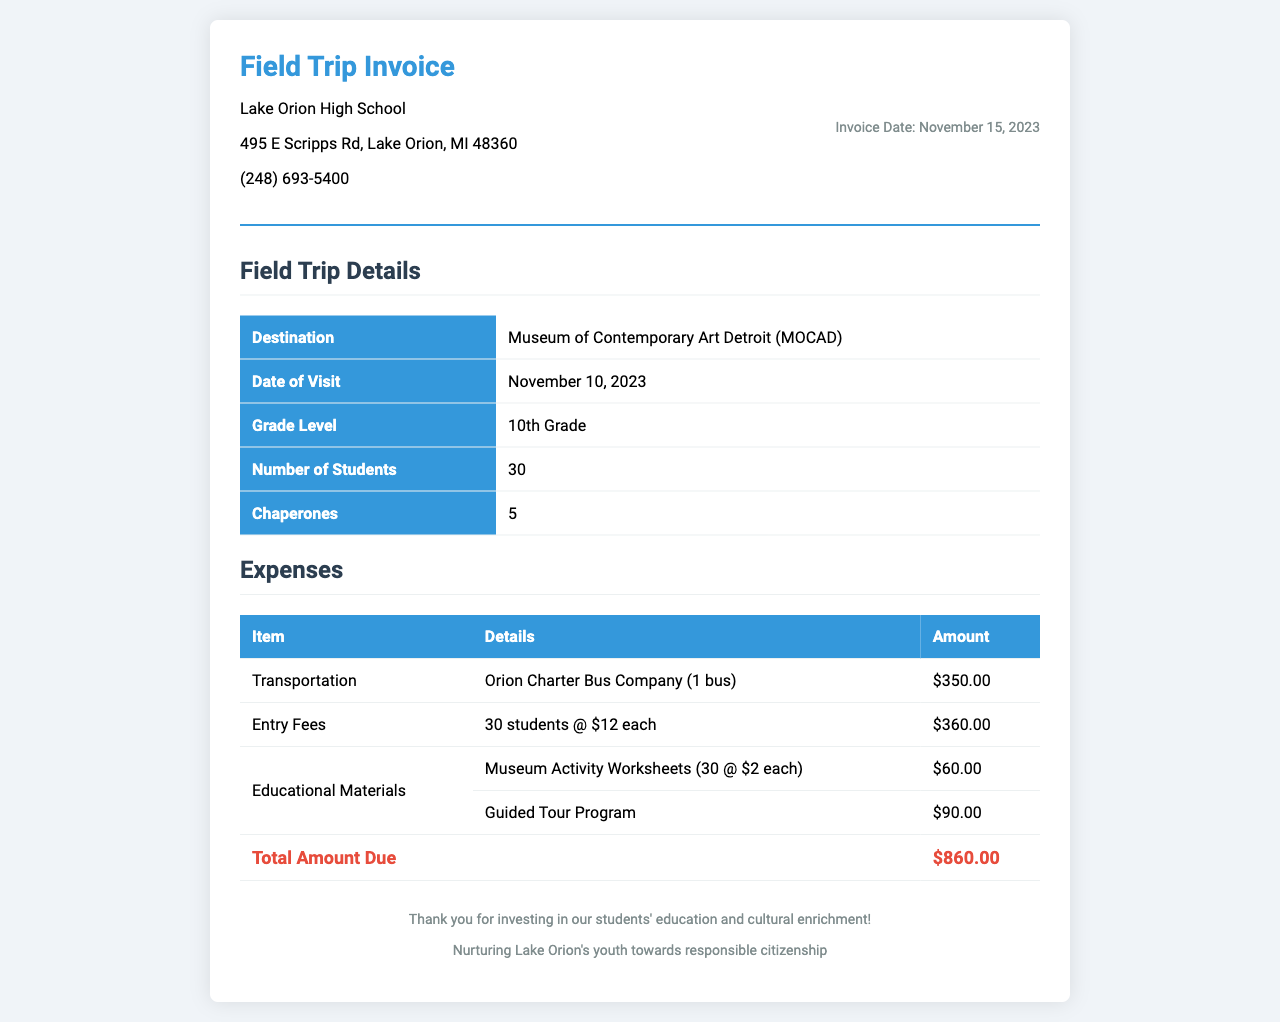what is the invoice date? The invoice date is clearly stated in the document as November 15, 2023.
Answer: November 15, 2023 what is the total amount due? The total amount due is summarized at the end of the expenses section, which is $860.00.
Answer: $860.00 how many students participated in the field trip? The document specifies that there were 30 students attending the field trip.
Answer: 30 who is the transportation provider? The transportation provider listed in the invoice is Orion Charter Bus Company.
Answer: Orion Charter Bus Company what is the date of the museum visit? The date of the museum visit is indicated as November 10, 2023.
Answer: November 10, 2023 how many chaperones were present during the field trip? The invoice states that there were 5 chaperones accompanying the students.
Answer: 5 how much were the entry fees per student? The entry fees per student are detailed to be $12 each in the expenses section.
Answer: $12 what educational material cost $90.00? The guided tour program is the educational material listed with the cost of $90.00.
Answer: Guided Tour Program what is the purpose of this invoice? The purpose of the invoice is to detail the expenses incurred for a school field trip related to education.
Answer: Expenses for a school field trip 